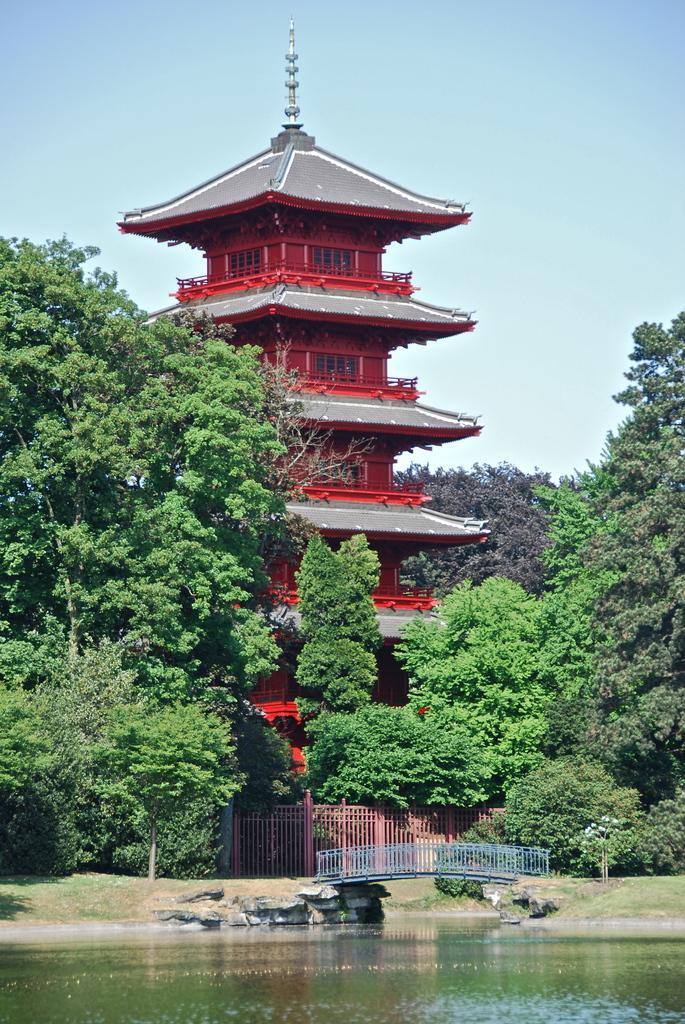How would you summarize this image in a sentence or two? In this image there is the sky, there is the building, there are trees, there are trees truncated towards the right of the image, there are trees truncated towards the left of the image, there is a river truncated towards the bottom of the image, there is a fencing, there is the grass. 